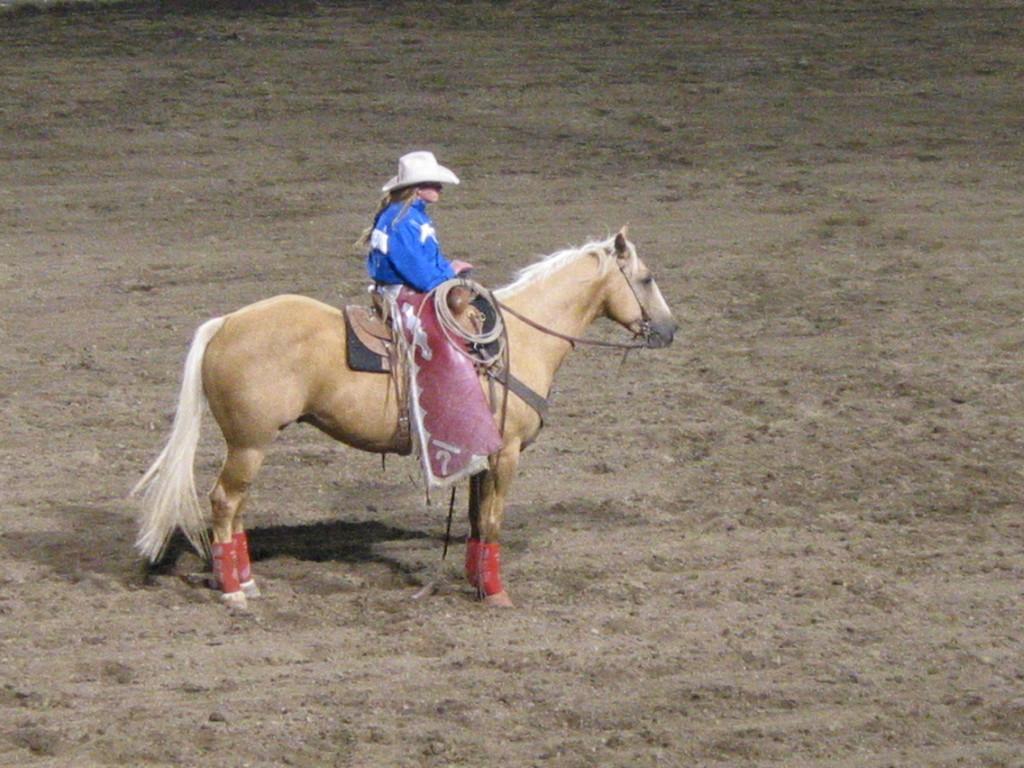In one or two sentences, can you explain what this image depicts? In this image I can see the person sitting on the horse and the horse is in brown color. 